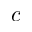<formula> <loc_0><loc_0><loc_500><loc_500>c</formula> 